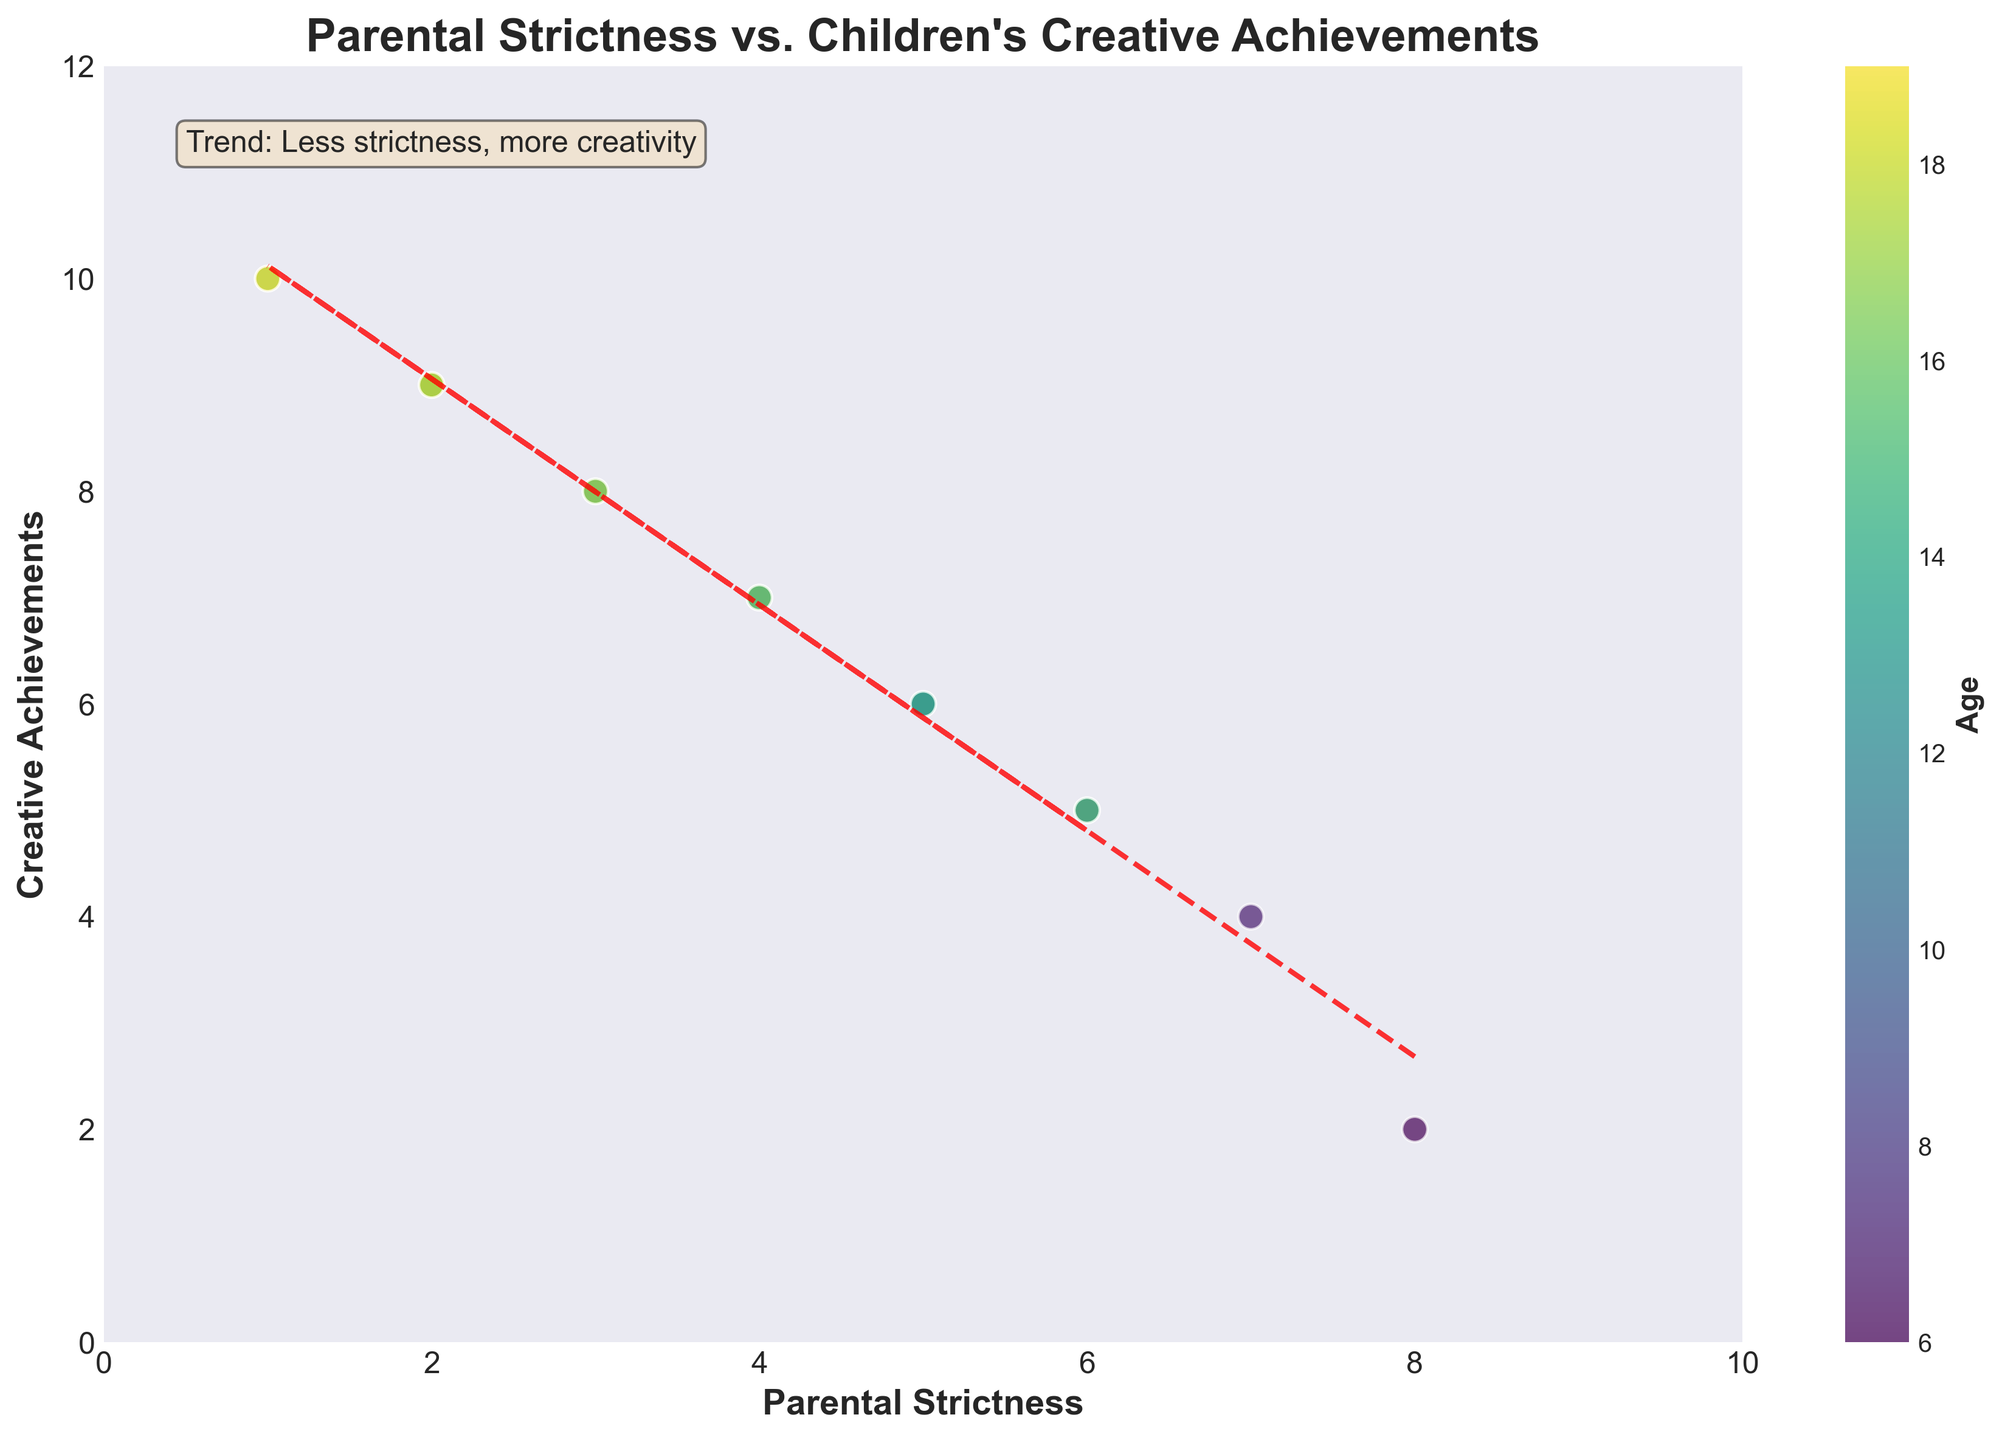Does the figure show a relationship between Parental Strictness and Children's Creative Achievements? The trend line indicates the relationship, showing that as Parental Strictness decreases, Creative Achievements increase.
Answer: Yes What is the title of the figure? Look at the text at the top of the figure to find the title.
Answer: Parental Strictness vs. Children's Creative Achievements What is the color of the trend line? Observe the line that fits through the data points, typically a different color from the scatter points.
Answer: Red What does the color bar represent in the figure? The color bar is usually present to indicate another dimension of data; in this case, it represents Age.
Answer: Age How many data points are displayed on the scatter plot? Count each of the individual data points presented in the figure.
Answer: 14 What ages have the highest creative achievements? Check the color bar and look for the highest Creative Achievements value, then find the corresponding Age values. Ages with Creative Achievements = 10 are highest.
Answer: 13, 19 Which age group had an intermediate level of parental strictness but varying creative achievements? Identify data points with a moderate value of parental strictness (e.g., 5 or 6) and then check the ages attached to those points. Ages with Parental Strictness = 5 have Creative Achievements of 6. Ages with Parental Strictness = 6 have Creative Achievements of 5.
Answer: 14, 15 What is the parental strictness value associated with the lowest creative achievements? Examine the data points to find the minimum value of Creative Achievements and then determine its corresponding Parental Strictness value. The lowest Creative Achievements is 2 and its corresponding Parental Strictness value is 8.
Answer: 8 What general trend is mentioned in the text annotation of the plot? Read the text annotation inside the figure, which usually provides a summary or key insight from the plot.
Answer: Less strictness, more creativity Does the plot show any outliers where high parental strictness coincided with high creative achievements? Find points where both Parental Strictness and Creative Achievements are high compared to the general trend. High Parental Strictness defined as 7 or 8. Creative Achievements defined as > 5.
Answer: No 